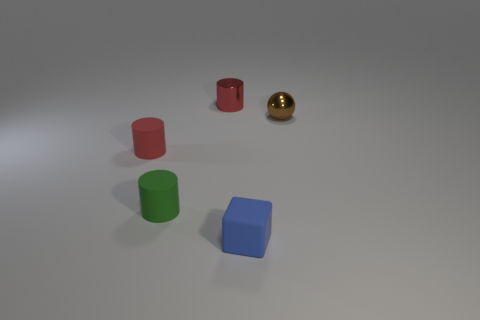Subtract all tiny red cylinders. How many cylinders are left? 1 Subtract all yellow spheres. How many red cylinders are left? 2 Add 5 purple rubber balls. How many objects exist? 10 Subtract all cylinders. How many objects are left? 2 Add 2 small metal spheres. How many small metal spheres are left? 3 Add 3 small green rubber things. How many small green rubber things exist? 4 Subtract 0 gray spheres. How many objects are left? 5 Subtract all tiny brown objects. Subtract all red rubber cylinders. How many objects are left? 3 